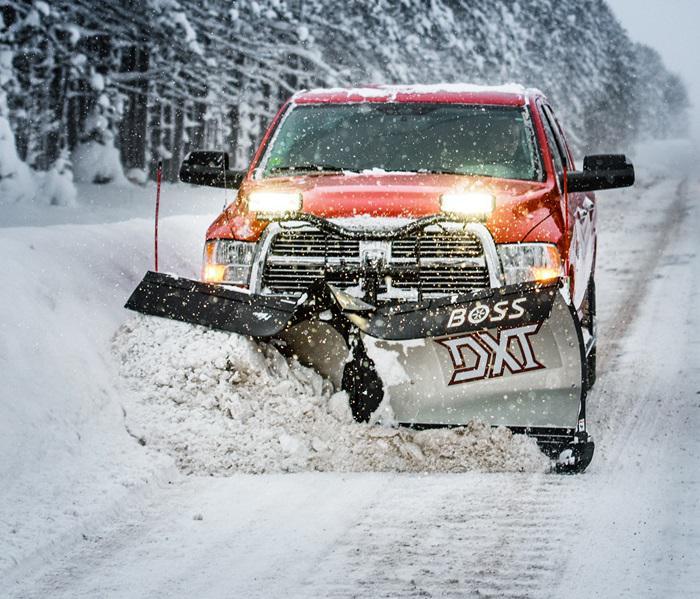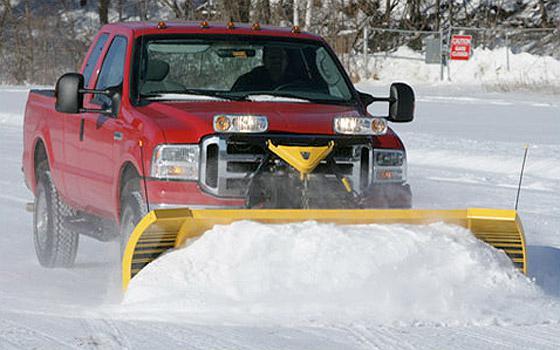The first image is the image on the left, the second image is the image on the right. Analyze the images presented: Is the assertion "there is at least one red truck in the image" valid? Answer yes or no. Yes. 